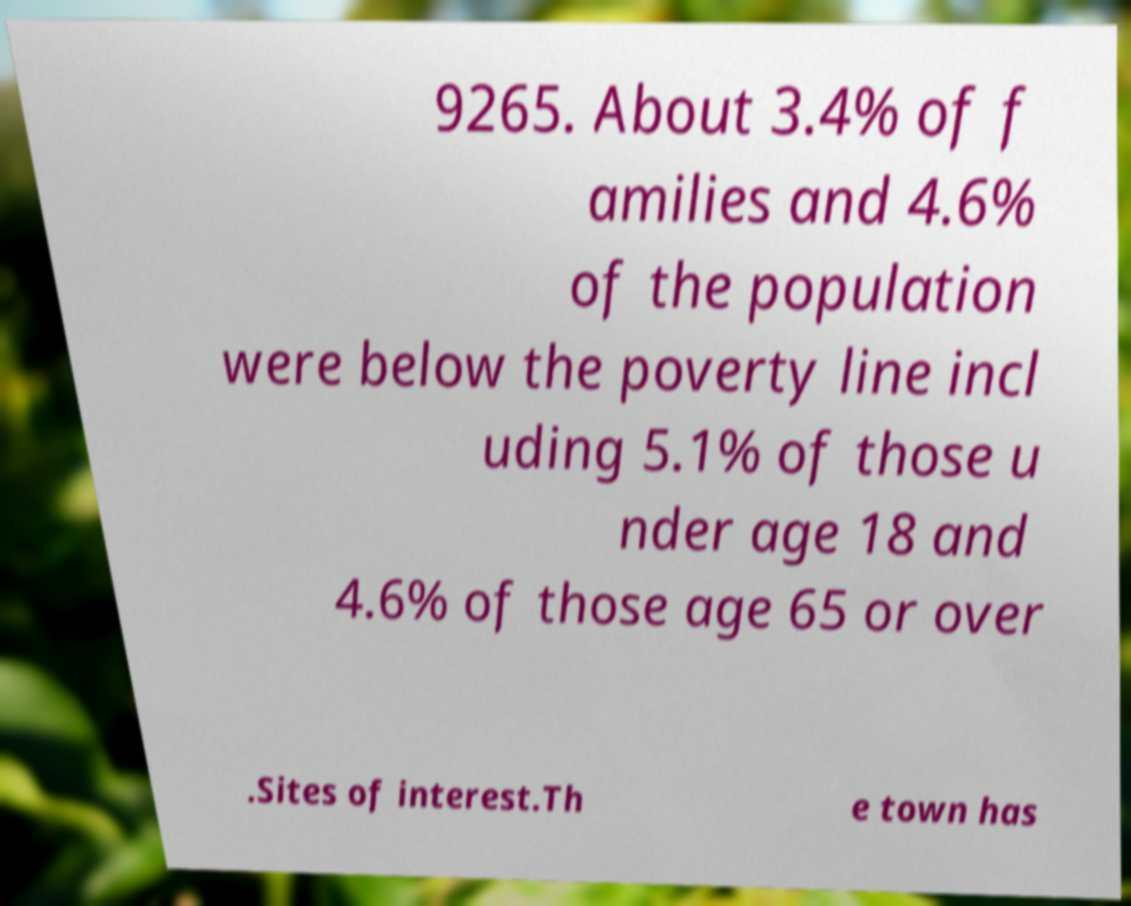Please read and relay the text visible in this image. What does it say? 9265. About 3.4% of f amilies and 4.6% of the population were below the poverty line incl uding 5.1% of those u nder age 18 and 4.6% of those age 65 or over .Sites of interest.Th e town has 